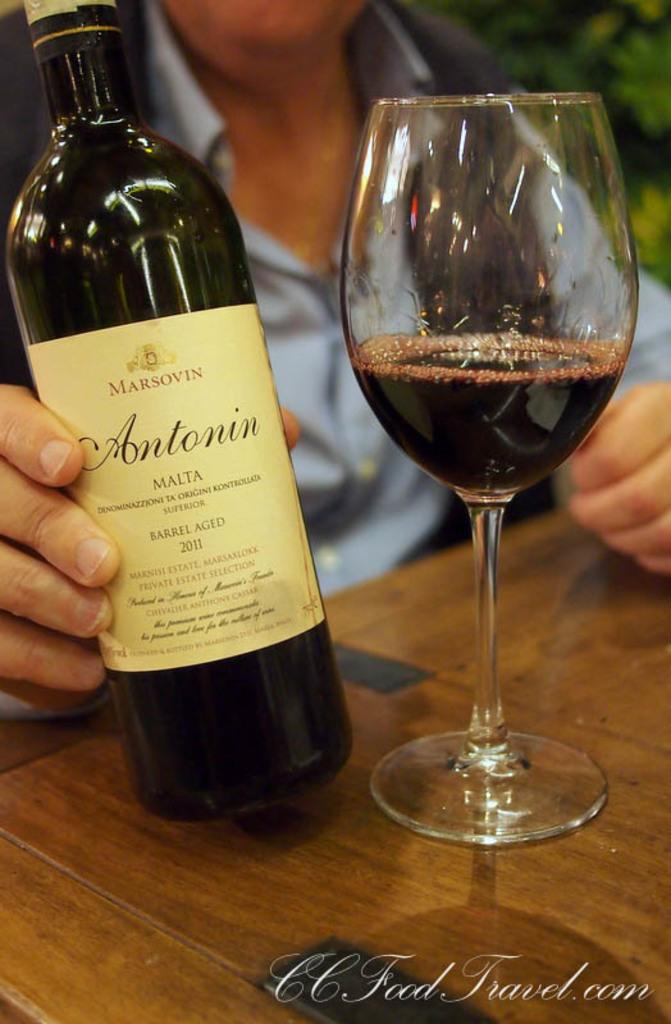Who made this wine?
Your response must be concise. Marsovin. 